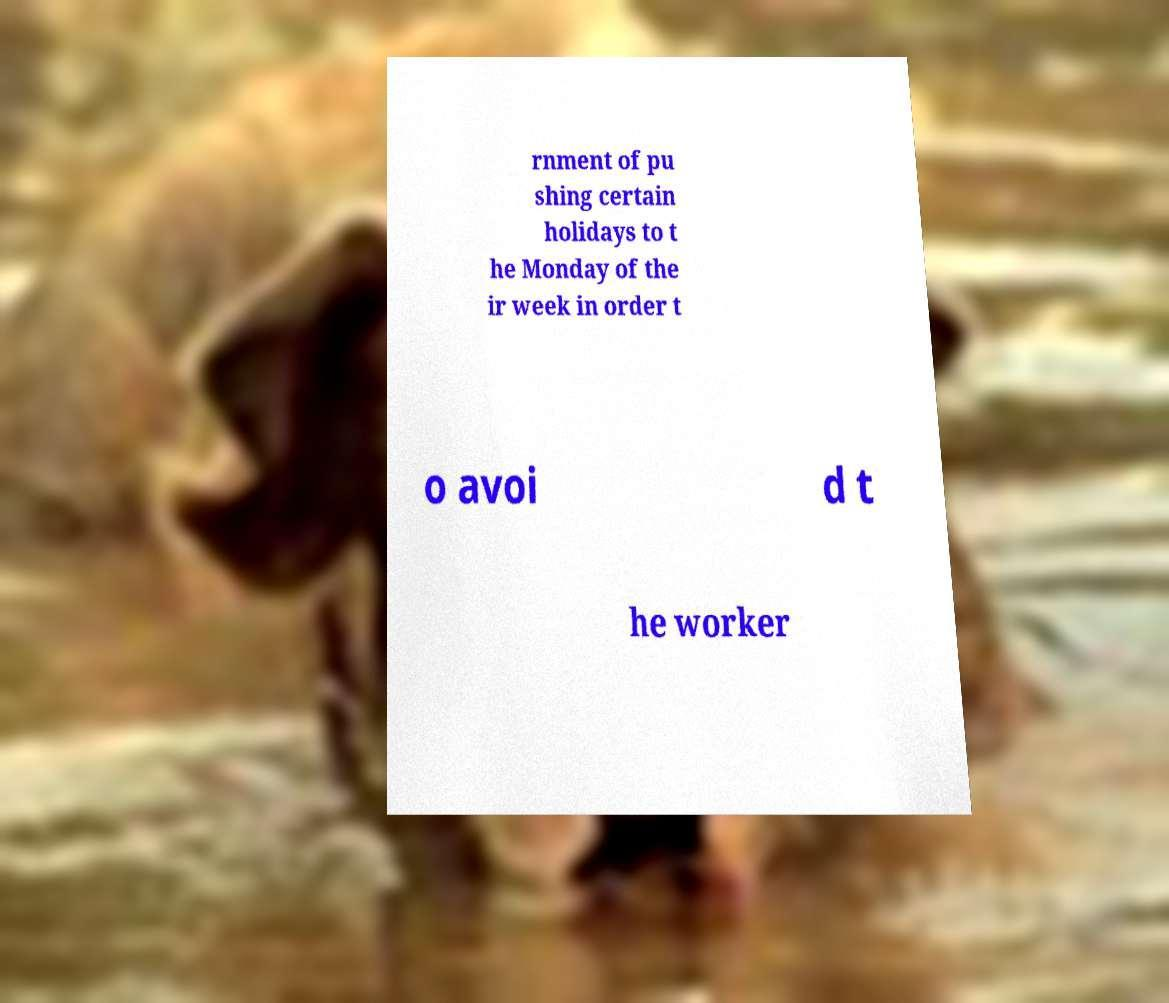Please identify and transcribe the text found in this image. rnment of pu shing certain holidays to t he Monday of the ir week in order t o avoi d t he worker 